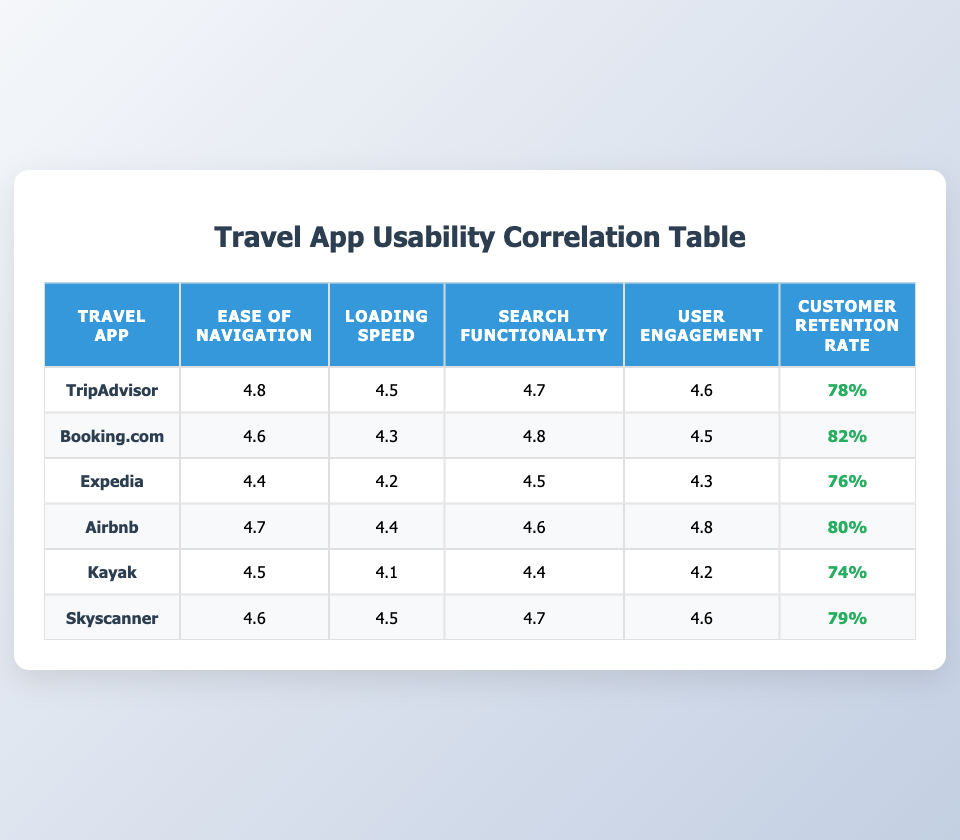What is the customer retention rate for Booking.com? The table lists Booking.com's customer retention rate directly under the "Customer Retention Rate" column, which shows 82%.
Answer: 82% Which travel app has the highest ease of navigation rating? Looking at the "Ease of Navigation" column, TripAdvisor has the highest rating of 4.8, compared to other apps.
Answer: TripAdvisor What is the average loading speed rating across all listed travel apps? The loading speed ratings from the apps are 4.5, 4.3, 4.2, 4.4, 4.1, and 4.5. Adding these gives 4.5 + 4.3 + 4.2 + 4.4 + 4.1 + 4.5 = 26.0. Dividing by 6 gives an average of 26.0 / 6 = 4.33.
Answer: 4.33 Is the customer retention rate for Airbnb greater than the average retention rate of the other apps combined? First, we find the average retention rate of the other apps (TripAdvisor, Booking.com, Expedia, Kayak, Skyscanner), which is (78 + 82 + 76 + 74 + 79) / 5 = 77.8. Airbnb's rate is 80, which is greater than 77.8.
Answer: Yes What is the difference in customer retention rates between the highest and lowest rated apps? The highest retention rate is 82% from Booking.com and the lowest is 74% from Kayak. Subtracting these gives 82 - 74 = 8%.
Answer: 8% Which app has the lowest user engagement rating, and what is that rating? By inspecting the "User Engagement" column, Kayak has the lowest rating of 4.2 compared to others.
Answer: Kayak, 4.2 Do any of the apps have a loading speed rating of 4.5? Scanning through the "Loading Speed" column, TripAdvisor, Airbnb, and Skyscanner each have a rating of 4.5. Therefore, the answer is yes.
Answer: Yes Which travel app shows a drop in user engagement, considering its ease of navigation rating? Examining the data, Expedia has lower ratings across both categories (Ease of Navigation at 4.4 and User Engagement at 4.3) compared to others with higher ease of navigation but lower engagement. Thus, it shows a drop.
Answer: Expedia What is the search functionality rating for Skyscanner? The table shows Skyscanner's "Search Functionality" rating directly as 4.7.
Answer: 4.7 